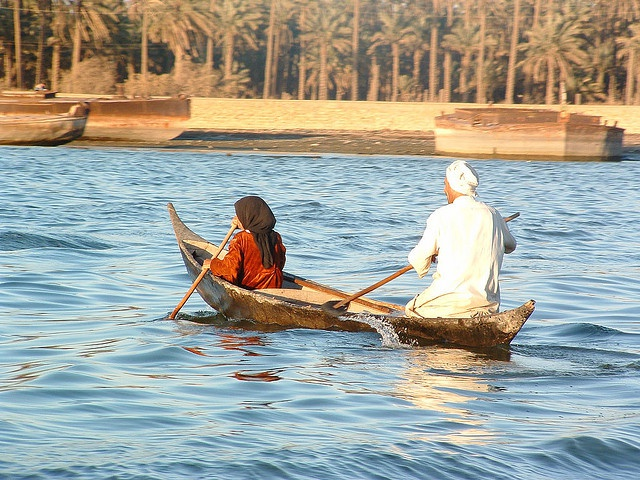Describe the objects in this image and their specific colors. I can see boat in gray, maroon, and black tones, people in gray, ivory, khaki, darkgray, and tan tones, boat in gray and tan tones, boat in gray, tan, and brown tones, and people in gray, maroon, black, brown, and red tones in this image. 